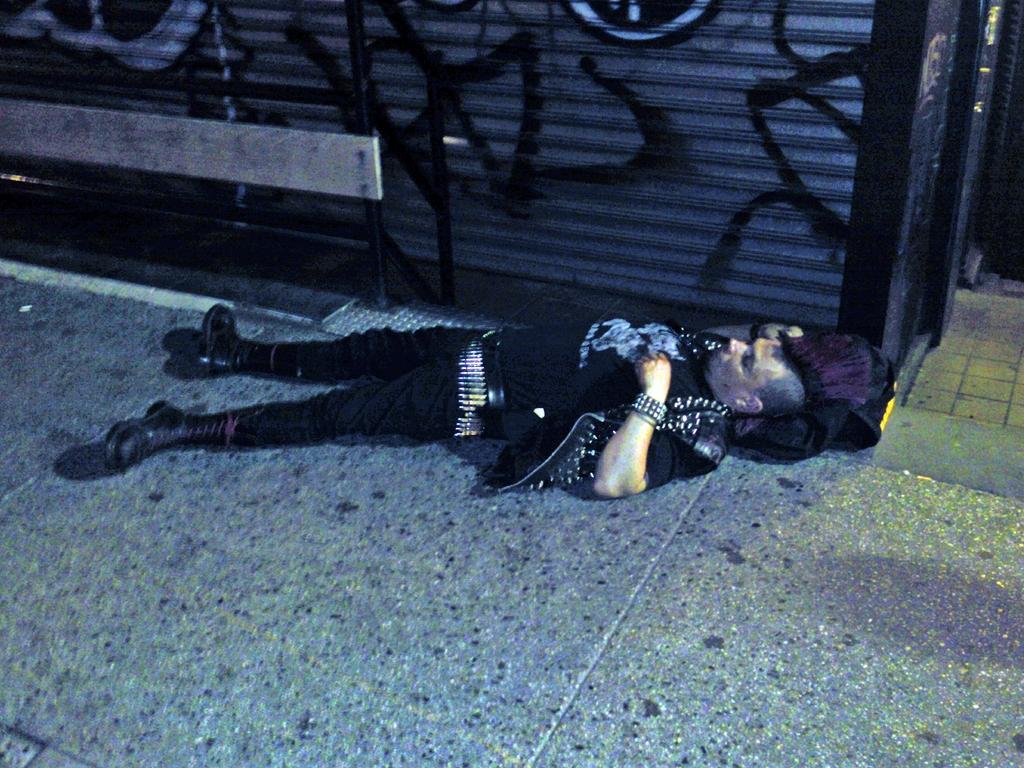In one or two sentences, can you explain what this image depicts? In this image we can see a man is lying on the floor. He is wearing black color dress and cloth is there under his head. We can see shutter and metal pole at the top of the image. 